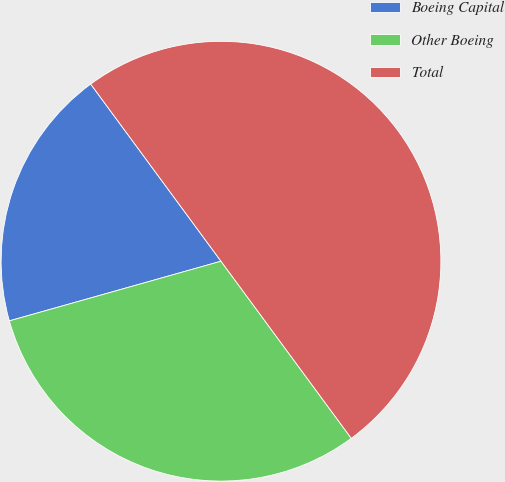Convert chart. <chart><loc_0><loc_0><loc_500><loc_500><pie_chart><fcel>Boeing Capital<fcel>Other Boeing<fcel>Total<nl><fcel>19.28%<fcel>30.72%<fcel>50.0%<nl></chart> 